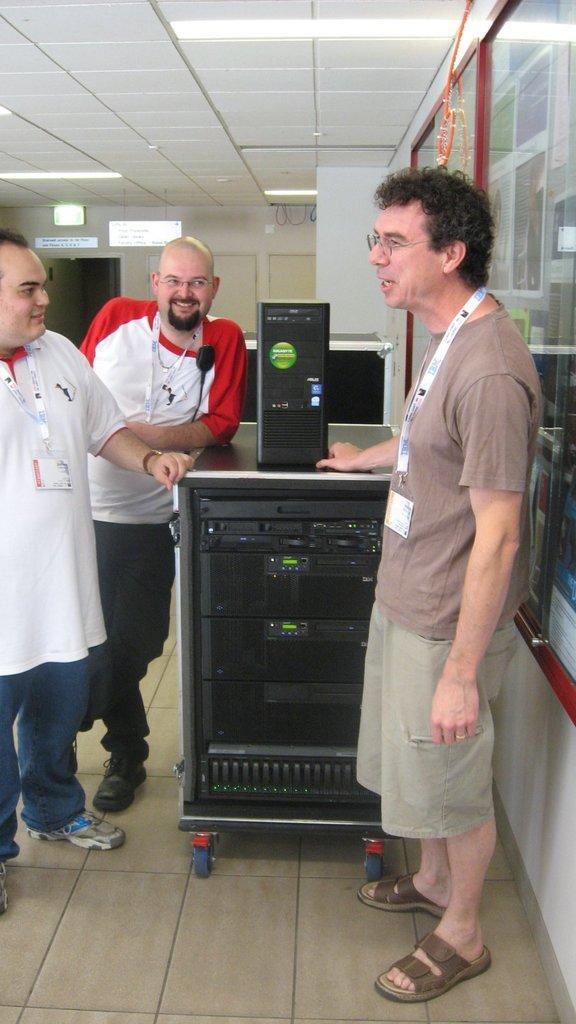How would you summarize this image in a sentence or two? In this picture I can see three people with a smile standing on the floor. I can see electronic devices. I can see light arrangements on the roof. 